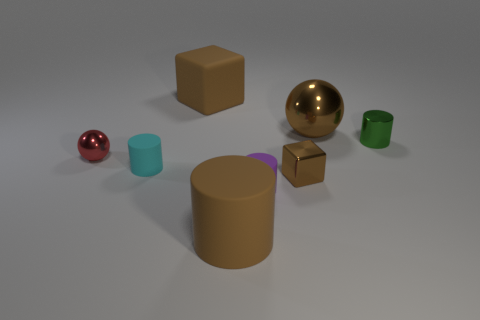There is another small ball that is the same material as the brown sphere; what color is it?
Provide a short and direct response. Red. Is the number of red spheres less than the number of tiny gray cubes?
Your answer should be very brief. No. There is a brown thing that is on the left side of the brown metal cube and in front of the small cyan rubber cylinder; what is its material?
Offer a very short reply. Rubber. Are there any brown metal objects on the right side of the brown metallic thing in front of the cyan object?
Provide a succinct answer. Yes. What number of small matte objects have the same color as the big cylinder?
Offer a terse response. 0. There is a small cube that is the same color as the large cube; what is it made of?
Provide a short and direct response. Metal. Are the tiny brown object and the small purple object made of the same material?
Offer a terse response. No. There is a tiny red object; are there any small blocks behind it?
Your answer should be compact. No. What is the material of the ball that is behind the metallic sphere in front of the large brown metal sphere?
Your answer should be very brief. Metal. The purple object that is the same shape as the tiny cyan matte object is what size?
Give a very brief answer. Small. 